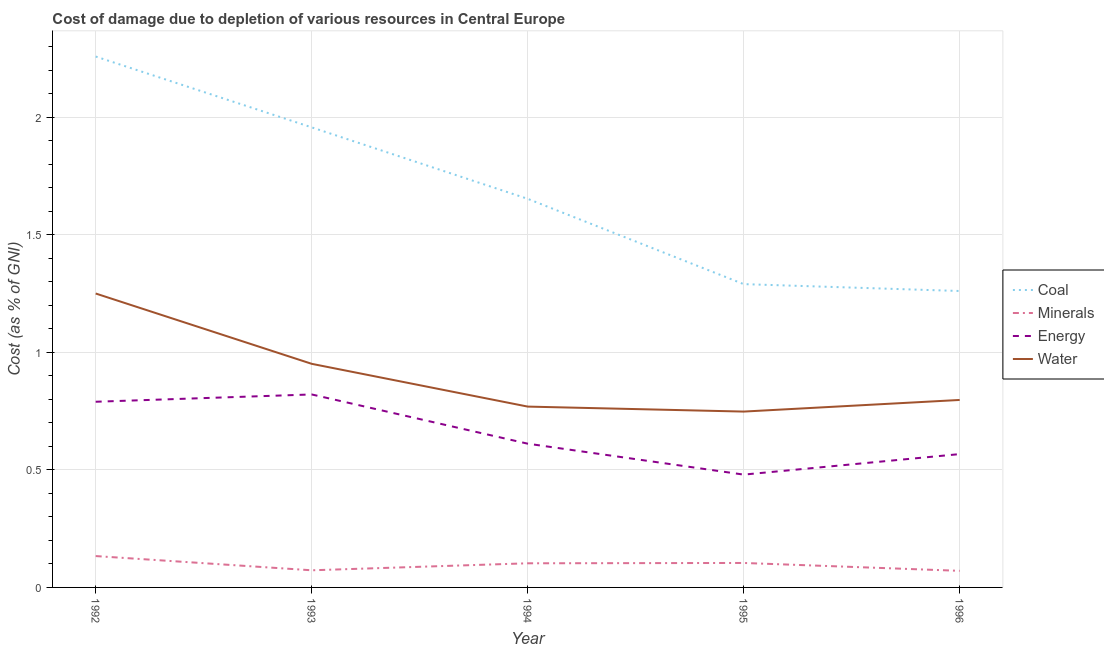How many different coloured lines are there?
Make the answer very short. 4. Does the line corresponding to cost of damage due to depletion of coal intersect with the line corresponding to cost of damage due to depletion of water?
Your answer should be compact. No. Is the number of lines equal to the number of legend labels?
Your answer should be compact. Yes. What is the cost of damage due to depletion of energy in 1996?
Your response must be concise. 0.57. Across all years, what is the maximum cost of damage due to depletion of energy?
Ensure brevity in your answer.  0.82. Across all years, what is the minimum cost of damage due to depletion of minerals?
Ensure brevity in your answer.  0.07. What is the total cost of damage due to depletion of energy in the graph?
Your answer should be very brief. 3.27. What is the difference between the cost of damage due to depletion of coal in 1995 and that in 1996?
Your answer should be very brief. 0.03. What is the difference between the cost of damage due to depletion of energy in 1994 and the cost of damage due to depletion of coal in 1995?
Give a very brief answer. -0.68. What is the average cost of damage due to depletion of minerals per year?
Your response must be concise. 0.1. In the year 1993, what is the difference between the cost of damage due to depletion of minerals and cost of damage due to depletion of coal?
Give a very brief answer. -1.88. In how many years, is the cost of damage due to depletion of water greater than 0.2 %?
Your response must be concise. 5. What is the ratio of the cost of damage due to depletion of minerals in 1992 to that in 1996?
Your response must be concise. 1.89. Is the difference between the cost of damage due to depletion of energy in 1993 and 1995 greater than the difference between the cost of damage due to depletion of water in 1993 and 1995?
Offer a terse response. Yes. What is the difference between the highest and the second highest cost of damage due to depletion of energy?
Give a very brief answer. 0.03. What is the difference between the highest and the lowest cost of damage due to depletion of minerals?
Keep it short and to the point. 0.06. Is the sum of the cost of damage due to depletion of minerals in 1992 and 1995 greater than the maximum cost of damage due to depletion of water across all years?
Provide a short and direct response. No. Is it the case that in every year, the sum of the cost of damage due to depletion of water and cost of damage due to depletion of energy is greater than the sum of cost of damage due to depletion of coal and cost of damage due to depletion of minerals?
Provide a short and direct response. No. Does the cost of damage due to depletion of minerals monotonically increase over the years?
Give a very brief answer. No. Is the cost of damage due to depletion of energy strictly less than the cost of damage due to depletion of coal over the years?
Offer a very short reply. Yes. What is the difference between two consecutive major ticks on the Y-axis?
Make the answer very short. 0.5. Are the values on the major ticks of Y-axis written in scientific E-notation?
Provide a short and direct response. No. Does the graph contain any zero values?
Your answer should be very brief. No. Does the graph contain grids?
Your answer should be compact. Yes. Where does the legend appear in the graph?
Your answer should be compact. Center right. What is the title of the graph?
Offer a very short reply. Cost of damage due to depletion of various resources in Central Europe . Does "First 20% of population" appear as one of the legend labels in the graph?
Offer a very short reply. No. What is the label or title of the Y-axis?
Keep it short and to the point. Cost (as % of GNI). What is the Cost (as % of GNI) in Coal in 1992?
Provide a succinct answer. 2.26. What is the Cost (as % of GNI) in Minerals in 1992?
Offer a terse response. 0.13. What is the Cost (as % of GNI) in Energy in 1992?
Offer a very short reply. 0.79. What is the Cost (as % of GNI) in Water in 1992?
Provide a succinct answer. 1.25. What is the Cost (as % of GNI) of Coal in 1993?
Make the answer very short. 1.96. What is the Cost (as % of GNI) in Minerals in 1993?
Your answer should be compact. 0.07. What is the Cost (as % of GNI) of Energy in 1993?
Make the answer very short. 0.82. What is the Cost (as % of GNI) in Water in 1993?
Your answer should be compact. 0.95. What is the Cost (as % of GNI) in Coal in 1994?
Provide a succinct answer. 1.65. What is the Cost (as % of GNI) of Minerals in 1994?
Make the answer very short. 0.1. What is the Cost (as % of GNI) in Energy in 1994?
Provide a succinct answer. 0.61. What is the Cost (as % of GNI) of Water in 1994?
Make the answer very short. 0.77. What is the Cost (as % of GNI) of Coal in 1995?
Offer a terse response. 1.29. What is the Cost (as % of GNI) of Minerals in 1995?
Keep it short and to the point. 0.1. What is the Cost (as % of GNI) in Energy in 1995?
Your answer should be very brief. 0.48. What is the Cost (as % of GNI) of Water in 1995?
Your response must be concise. 0.75. What is the Cost (as % of GNI) of Coal in 1996?
Provide a short and direct response. 1.26. What is the Cost (as % of GNI) of Minerals in 1996?
Provide a succinct answer. 0.07. What is the Cost (as % of GNI) in Energy in 1996?
Make the answer very short. 0.57. What is the Cost (as % of GNI) in Water in 1996?
Provide a succinct answer. 0.8. Across all years, what is the maximum Cost (as % of GNI) of Coal?
Ensure brevity in your answer.  2.26. Across all years, what is the maximum Cost (as % of GNI) in Minerals?
Offer a very short reply. 0.13. Across all years, what is the maximum Cost (as % of GNI) in Energy?
Provide a succinct answer. 0.82. Across all years, what is the maximum Cost (as % of GNI) of Water?
Ensure brevity in your answer.  1.25. Across all years, what is the minimum Cost (as % of GNI) in Coal?
Your answer should be compact. 1.26. Across all years, what is the minimum Cost (as % of GNI) of Minerals?
Your response must be concise. 0.07. Across all years, what is the minimum Cost (as % of GNI) of Energy?
Offer a terse response. 0.48. Across all years, what is the minimum Cost (as % of GNI) in Water?
Keep it short and to the point. 0.75. What is the total Cost (as % of GNI) of Coal in the graph?
Your response must be concise. 8.42. What is the total Cost (as % of GNI) of Minerals in the graph?
Give a very brief answer. 0.48. What is the total Cost (as % of GNI) of Energy in the graph?
Provide a short and direct response. 3.27. What is the total Cost (as % of GNI) of Water in the graph?
Ensure brevity in your answer.  4.52. What is the difference between the Cost (as % of GNI) of Coal in 1992 and that in 1993?
Offer a terse response. 0.3. What is the difference between the Cost (as % of GNI) of Minerals in 1992 and that in 1993?
Keep it short and to the point. 0.06. What is the difference between the Cost (as % of GNI) in Energy in 1992 and that in 1993?
Your response must be concise. -0.03. What is the difference between the Cost (as % of GNI) of Water in 1992 and that in 1993?
Your answer should be compact. 0.3. What is the difference between the Cost (as % of GNI) of Coal in 1992 and that in 1994?
Keep it short and to the point. 0.61. What is the difference between the Cost (as % of GNI) in Minerals in 1992 and that in 1994?
Give a very brief answer. 0.03. What is the difference between the Cost (as % of GNI) of Energy in 1992 and that in 1994?
Keep it short and to the point. 0.18. What is the difference between the Cost (as % of GNI) in Water in 1992 and that in 1994?
Provide a succinct answer. 0.48. What is the difference between the Cost (as % of GNI) in Coal in 1992 and that in 1995?
Your answer should be very brief. 0.97. What is the difference between the Cost (as % of GNI) of Minerals in 1992 and that in 1995?
Your answer should be compact. 0.03. What is the difference between the Cost (as % of GNI) in Energy in 1992 and that in 1995?
Provide a short and direct response. 0.31. What is the difference between the Cost (as % of GNI) in Water in 1992 and that in 1995?
Your answer should be very brief. 0.5. What is the difference between the Cost (as % of GNI) of Coal in 1992 and that in 1996?
Provide a short and direct response. 1. What is the difference between the Cost (as % of GNI) of Minerals in 1992 and that in 1996?
Make the answer very short. 0.06. What is the difference between the Cost (as % of GNI) in Energy in 1992 and that in 1996?
Offer a terse response. 0.22. What is the difference between the Cost (as % of GNI) in Water in 1992 and that in 1996?
Keep it short and to the point. 0.45. What is the difference between the Cost (as % of GNI) of Coal in 1993 and that in 1994?
Offer a terse response. 0.3. What is the difference between the Cost (as % of GNI) in Minerals in 1993 and that in 1994?
Offer a terse response. -0.03. What is the difference between the Cost (as % of GNI) of Energy in 1993 and that in 1994?
Provide a short and direct response. 0.21. What is the difference between the Cost (as % of GNI) of Water in 1993 and that in 1994?
Your answer should be very brief. 0.18. What is the difference between the Cost (as % of GNI) of Coal in 1993 and that in 1995?
Make the answer very short. 0.67. What is the difference between the Cost (as % of GNI) of Minerals in 1993 and that in 1995?
Your answer should be very brief. -0.03. What is the difference between the Cost (as % of GNI) of Energy in 1993 and that in 1995?
Give a very brief answer. 0.34. What is the difference between the Cost (as % of GNI) of Water in 1993 and that in 1995?
Your answer should be compact. 0.2. What is the difference between the Cost (as % of GNI) in Coal in 1993 and that in 1996?
Ensure brevity in your answer.  0.7. What is the difference between the Cost (as % of GNI) of Minerals in 1993 and that in 1996?
Provide a succinct answer. 0. What is the difference between the Cost (as % of GNI) of Energy in 1993 and that in 1996?
Your answer should be compact. 0.25. What is the difference between the Cost (as % of GNI) of Water in 1993 and that in 1996?
Offer a terse response. 0.15. What is the difference between the Cost (as % of GNI) in Coal in 1994 and that in 1995?
Provide a succinct answer. 0.36. What is the difference between the Cost (as % of GNI) in Minerals in 1994 and that in 1995?
Offer a very short reply. -0. What is the difference between the Cost (as % of GNI) of Energy in 1994 and that in 1995?
Offer a very short reply. 0.13. What is the difference between the Cost (as % of GNI) in Water in 1994 and that in 1995?
Give a very brief answer. 0.02. What is the difference between the Cost (as % of GNI) of Coal in 1994 and that in 1996?
Keep it short and to the point. 0.39. What is the difference between the Cost (as % of GNI) of Minerals in 1994 and that in 1996?
Ensure brevity in your answer.  0.03. What is the difference between the Cost (as % of GNI) of Energy in 1994 and that in 1996?
Give a very brief answer. 0.04. What is the difference between the Cost (as % of GNI) of Water in 1994 and that in 1996?
Provide a succinct answer. -0.03. What is the difference between the Cost (as % of GNI) of Coal in 1995 and that in 1996?
Provide a short and direct response. 0.03. What is the difference between the Cost (as % of GNI) of Minerals in 1995 and that in 1996?
Provide a short and direct response. 0.03. What is the difference between the Cost (as % of GNI) in Energy in 1995 and that in 1996?
Offer a very short reply. -0.09. What is the difference between the Cost (as % of GNI) of Water in 1995 and that in 1996?
Ensure brevity in your answer.  -0.05. What is the difference between the Cost (as % of GNI) in Coal in 1992 and the Cost (as % of GNI) in Minerals in 1993?
Provide a short and direct response. 2.19. What is the difference between the Cost (as % of GNI) in Coal in 1992 and the Cost (as % of GNI) in Energy in 1993?
Ensure brevity in your answer.  1.44. What is the difference between the Cost (as % of GNI) of Coal in 1992 and the Cost (as % of GNI) of Water in 1993?
Provide a succinct answer. 1.31. What is the difference between the Cost (as % of GNI) in Minerals in 1992 and the Cost (as % of GNI) in Energy in 1993?
Your answer should be compact. -0.69. What is the difference between the Cost (as % of GNI) of Minerals in 1992 and the Cost (as % of GNI) of Water in 1993?
Provide a short and direct response. -0.82. What is the difference between the Cost (as % of GNI) in Energy in 1992 and the Cost (as % of GNI) in Water in 1993?
Offer a terse response. -0.16. What is the difference between the Cost (as % of GNI) of Coal in 1992 and the Cost (as % of GNI) of Minerals in 1994?
Offer a very short reply. 2.16. What is the difference between the Cost (as % of GNI) in Coal in 1992 and the Cost (as % of GNI) in Energy in 1994?
Give a very brief answer. 1.65. What is the difference between the Cost (as % of GNI) of Coal in 1992 and the Cost (as % of GNI) of Water in 1994?
Keep it short and to the point. 1.49. What is the difference between the Cost (as % of GNI) of Minerals in 1992 and the Cost (as % of GNI) of Energy in 1994?
Your answer should be very brief. -0.48. What is the difference between the Cost (as % of GNI) of Minerals in 1992 and the Cost (as % of GNI) of Water in 1994?
Offer a very short reply. -0.64. What is the difference between the Cost (as % of GNI) in Energy in 1992 and the Cost (as % of GNI) in Water in 1994?
Offer a very short reply. 0.02. What is the difference between the Cost (as % of GNI) in Coal in 1992 and the Cost (as % of GNI) in Minerals in 1995?
Keep it short and to the point. 2.15. What is the difference between the Cost (as % of GNI) of Coal in 1992 and the Cost (as % of GNI) of Energy in 1995?
Offer a very short reply. 1.78. What is the difference between the Cost (as % of GNI) in Coal in 1992 and the Cost (as % of GNI) in Water in 1995?
Provide a short and direct response. 1.51. What is the difference between the Cost (as % of GNI) in Minerals in 1992 and the Cost (as % of GNI) in Energy in 1995?
Give a very brief answer. -0.35. What is the difference between the Cost (as % of GNI) in Minerals in 1992 and the Cost (as % of GNI) in Water in 1995?
Offer a terse response. -0.61. What is the difference between the Cost (as % of GNI) of Energy in 1992 and the Cost (as % of GNI) of Water in 1995?
Keep it short and to the point. 0.04. What is the difference between the Cost (as % of GNI) of Coal in 1992 and the Cost (as % of GNI) of Minerals in 1996?
Make the answer very short. 2.19. What is the difference between the Cost (as % of GNI) of Coal in 1992 and the Cost (as % of GNI) of Energy in 1996?
Offer a very short reply. 1.69. What is the difference between the Cost (as % of GNI) in Coal in 1992 and the Cost (as % of GNI) in Water in 1996?
Offer a terse response. 1.46. What is the difference between the Cost (as % of GNI) in Minerals in 1992 and the Cost (as % of GNI) in Energy in 1996?
Keep it short and to the point. -0.43. What is the difference between the Cost (as % of GNI) in Minerals in 1992 and the Cost (as % of GNI) in Water in 1996?
Make the answer very short. -0.66. What is the difference between the Cost (as % of GNI) of Energy in 1992 and the Cost (as % of GNI) of Water in 1996?
Your answer should be compact. -0.01. What is the difference between the Cost (as % of GNI) in Coal in 1993 and the Cost (as % of GNI) in Minerals in 1994?
Make the answer very short. 1.85. What is the difference between the Cost (as % of GNI) in Coal in 1993 and the Cost (as % of GNI) in Energy in 1994?
Keep it short and to the point. 1.35. What is the difference between the Cost (as % of GNI) in Coal in 1993 and the Cost (as % of GNI) in Water in 1994?
Offer a very short reply. 1.19. What is the difference between the Cost (as % of GNI) of Minerals in 1993 and the Cost (as % of GNI) of Energy in 1994?
Give a very brief answer. -0.54. What is the difference between the Cost (as % of GNI) in Minerals in 1993 and the Cost (as % of GNI) in Water in 1994?
Your answer should be very brief. -0.7. What is the difference between the Cost (as % of GNI) of Energy in 1993 and the Cost (as % of GNI) of Water in 1994?
Your answer should be compact. 0.05. What is the difference between the Cost (as % of GNI) in Coal in 1993 and the Cost (as % of GNI) in Minerals in 1995?
Keep it short and to the point. 1.85. What is the difference between the Cost (as % of GNI) in Coal in 1993 and the Cost (as % of GNI) in Energy in 1995?
Provide a short and direct response. 1.48. What is the difference between the Cost (as % of GNI) in Coal in 1993 and the Cost (as % of GNI) in Water in 1995?
Keep it short and to the point. 1.21. What is the difference between the Cost (as % of GNI) of Minerals in 1993 and the Cost (as % of GNI) of Energy in 1995?
Your answer should be compact. -0.41. What is the difference between the Cost (as % of GNI) in Minerals in 1993 and the Cost (as % of GNI) in Water in 1995?
Your answer should be compact. -0.68. What is the difference between the Cost (as % of GNI) of Energy in 1993 and the Cost (as % of GNI) of Water in 1995?
Keep it short and to the point. 0.07. What is the difference between the Cost (as % of GNI) of Coal in 1993 and the Cost (as % of GNI) of Minerals in 1996?
Your answer should be compact. 1.89. What is the difference between the Cost (as % of GNI) in Coal in 1993 and the Cost (as % of GNI) in Energy in 1996?
Keep it short and to the point. 1.39. What is the difference between the Cost (as % of GNI) in Coal in 1993 and the Cost (as % of GNI) in Water in 1996?
Ensure brevity in your answer.  1.16. What is the difference between the Cost (as % of GNI) of Minerals in 1993 and the Cost (as % of GNI) of Energy in 1996?
Provide a succinct answer. -0.49. What is the difference between the Cost (as % of GNI) of Minerals in 1993 and the Cost (as % of GNI) of Water in 1996?
Your answer should be very brief. -0.72. What is the difference between the Cost (as % of GNI) of Energy in 1993 and the Cost (as % of GNI) of Water in 1996?
Your response must be concise. 0.02. What is the difference between the Cost (as % of GNI) in Coal in 1994 and the Cost (as % of GNI) in Minerals in 1995?
Your response must be concise. 1.55. What is the difference between the Cost (as % of GNI) in Coal in 1994 and the Cost (as % of GNI) in Energy in 1995?
Offer a very short reply. 1.17. What is the difference between the Cost (as % of GNI) in Coal in 1994 and the Cost (as % of GNI) in Water in 1995?
Your answer should be compact. 0.91. What is the difference between the Cost (as % of GNI) of Minerals in 1994 and the Cost (as % of GNI) of Energy in 1995?
Your answer should be compact. -0.38. What is the difference between the Cost (as % of GNI) of Minerals in 1994 and the Cost (as % of GNI) of Water in 1995?
Your response must be concise. -0.65. What is the difference between the Cost (as % of GNI) in Energy in 1994 and the Cost (as % of GNI) in Water in 1995?
Your answer should be compact. -0.14. What is the difference between the Cost (as % of GNI) in Coal in 1994 and the Cost (as % of GNI) in Minerals in 1996?
Your response must be concise. 1.58. What is the difference between the Cost (as % of GNI) in Coal in 1994 and the Cost (as % of GNI) in Energy in 1996?
Your answer should be very brief. 1.09. What is the difference between the Cost (as % of GNI) in Coal in 1994 and the Cost (as % of GNI) in Water in 1996?
Give a very brief answer. 0.86. What is the difference between the Cost (as % of GNI) of Minerals in 1994 and the Cost (as % of GNI) of Energy in 1996?
Give a very brief answer. -0.46. What is the difference between the Cost (as % of GNI) in Minerals in 1994 and the Cost (as % of GNI) in Water in 1996?
Ensure brevity in your answer.  -0.69. What is the difference between the Cost (as % of GNI) in Energy in 1994 and the Cost (as % of GNI) in Water in 1996?
Your answer should be compact. -0.19. What is the difference between the Cost (as % of GNI) of Coal in 1995 and the Cost (as % of GNI) of Minerals in 1996?
Make the answer very short. 1.22. What is the difference between the Cost (as % of GNI) in Coal in 1995 and the Cost (as % of GNI) in Energy in 1996?
Give a very brief answer. 0.72. What is the difference between the Cost (as % of GNI) in Coal in 1995 and the Cost (as % of GNI) in Water in 1996?
Make the answer very short. 0.49. What is the difference between the Cost (as % of GNI) of Minerals in 1995 and the Cost (as % of GNI) of Energy in 1996?
Provide a short and direct response. -0.46. What is the difference between the Cost (as % of GNI) of Minerals in 1995 and the Cost (as % of GNI) of Water in 1996?
Your response must be concise. -0.69. What is the difference between the Cost (as % of GNI) of Energy in 1995 and the Cost (as % of GNI) of Water in 1996?
Give a very brief answer. -0.32. What is the average Cost (as % of GNI) of Coal per year?
Offer a very short reply. 1.68. What is the average Cost (as % of GNI) in Minerals per year?
Ensure brevity in your answer.  0.1. What is the average Cost (as % of GNI) in Energy per year?
Offer a very short reply. 0.65. What is the average Cost (as % of GNI) in Water per year?
Make the answer very short. 0.9. In the year 1992, what is the difference between the Cost (as % of GNI) of Coal and Cost (as % of GNI) of Minerals?
Ensure brevity in your answer.  2.12. In the year 1992, what is the difference between the Cost (as % of GNI) in Coal and Cost (as % of GNI) in Energy?
Offer a terse response. 1.47. In the year 1992, what is the difference between the Cost (as % of GNI) in Coal and Cost (as % of GNI) in Water?
Give a very brief answer. 1.01. In the year 1992, what is the difference between the Cost (as % of GNI) in Minerals and Cost (as % of GNI) in Energy?
Your response must be concise. -0.66. In the year 1992, what is the difference between the Cost (as % of GNI) in Minerals and Cost (as % of GNI) in Water?
Make the answer very short. -1.12. In the year 1992, what is the difference between the Cost (as % of GNI) in Energy and Cost (as % of GNI) in Water?
Make the answer very short. -0.46. In the year 1993, what is the difference between the Cost (as % of GNI) in Coal and Cost (as % of GNI) in Minerals?
Offer a very short reply. 1.88. In the year 1993, what is the difference between the Cost (as % of GNI) in Coal and Cost (as % of GNI) in Energy?
Your answer should be very brief. 1.14. In the year 1993, what is the difference between the Cost (as % of GNI) of Coal and Cost (as % of GNI) of Water?
Make the answer very short. 1.01. In the year 1993, what is the difference between the Cost (as % of GNI) in Minerals and Cost (as % of GNI) in Energy?
Give a very brief answer. -0.75. In the year 1993, what is the difference between the Cost (as % of GNI) in Minerals and Cost (as % of GNI) in Water?
Provide a succinct answer. -0.88. In the year 1993, what is the difference between the Cost (as % of GNI) of Energy and Cost (as % of GNI) of Water?
Ensure brevity in your answer.  -0.13. In the year 1994, what is the difference between the Cost (as % of GNI) of Coal and Cost (as % of GNI) of Minerals?
Your answer should be very brief. 1.55. In the year 1994, what is the difference between the Cost (as % of GNI) of Coal and Cost (as % of GNI) of Energy?
Provide a succinct answer. 1.04. In the year 1994, what is the difference between the Cost (as % of GNI) of Coal and Cost (as % of GNI) of Water?
Offer a very short reply. 0.88. In the year 1994, what is the difference between the Cost (as % of GNI) of Minerals and Cost (as % of GNI) of Energy?
Keep it short and to the point. -0.51. In the year 1994, what is the difference between the Cost (as % of GNI) in Minerals and Cost (as % of GNI) in Water?
Your answer should be very brief. -0.67. In the year 1994, what is the difference between the Cost (as % of GNI) of Energy and Cost (as % of GNI) of Water?
Ensure brevity in your answer.  -0.16. In the year 1995, what is the difference between the Cost (as % of GNI) of Coal and Cost (as % of GNI) of Minerals?
Keep it short and to the point. 1.19. In the year 1995, what is the difference between the Cost (as % of GNI) of Coal and Cost (as % of GNI) of Energy?
Offer a very short reply. 0.81. In the year 1995, what is the difference between the Cost (as % of GNI) of Coal and Cost (as % of GNI) of Water?
Ensure brevity in your answer.  0.54. In the year 1995, what is the difference between the Cost (as % of GNI) in Minerals and Cost (as % of GNI) in Energy?
Give a very brief answer. -0.38. In the year 1995, what is the difference between the Cost (as % of GNI) of Minerals and Cost (as % of GNI) of Water?
Make the answer very short. -0.64. In the year 1995, what is the difference between the Cost (as % of GNI) in Energy and Cost (as % of GNI) in Water?
Offer a very short reply. -0.27. In the year 1996, what is the difference between the Cost (as % of GNI) of Coal and Cost (as % of GNI) of Minerals?
Make the answer very short. 1.19. In the year 1996, what is the difference between the Cost (as % of GNI) in Coal and Cost (as % of GNI) in Energy?
Offer a very short reply. 0.69. In the year 1996, what is the difference between the Cost (as % of GNI) in Coal and Cost (as % of GNI) in Water?
Make the answer very short. 0.46. In the year 1996, what is the difference between the Cost (as % of GNI) in Minerals and Cost (as % of GNI) in Energy?
Offer a terse response. -0.5. In the year 1996, what is the difference between the Cost (as % of GNI) of Minerals and Cost (as % of GNI) of Water?
Ensure brevity in your answer.  -0.73. In the year 1996, what is the difference between the Cost (as % of GNI) of Energy and Cost (as % of GNI) of Water?
Keep it short and to the point. -0.23. What is the ratio of the Cost (as % of GNI) in Coal in 1992 to that in 1993?
Give a very brief answer. 1.15. What is the ratio of the Cost (as % of GNI) of Minerals in 1992 to that in 1993?
Your answer should be very brief. 1.83. What is the ratio of the Cost (as % of GNI) in Energy in 1992 to that in 1993?
Ensure brevity in your answer.  0.96. What is the ratio of the Cost (as % of GNI) of Water in 1992 to that in 1993?
Offer a very short reply. 1.31. What is the ratio of the Cost (as % of GNI) of Coal in 1992 to that in 1994?
Keep it short and to the point. 1.37. What is the ratio of the Cost (as % of GNI) in Minerals in 1992 to that in 1994?
Keep it short and to the point. 1.3. What is the ratio of the Cost (as % of GNI) in Energy in 1992 to that in 1994?
Give a very brief answer. 1.29. What is the ratio of the Cost (as % of GNI) of Water in 1992 to that in 1994?
Offer a very short reply. 1.63. What is the ratio of the Cost (as % of GNI) of Coal in 1992 to that in 1995?
Ensure brevity in your answer.  1.75. What is the ratio of the Cost (as % of GNI) in Minerals in 1992 to that in 1995?
Offer a very short reply. 1.28. What is the ratio of the Cost (as % of GNI) of Energy in 1992 to that in 1995?
Make the answer very short. 1.65. What is the ratio of the Cost (as % of GNI) of Water in 1992 to that in 1995?
Offer a terse response. 1.67. What is the ratio of the Cost (as % of GNI) in Coal in 1992 to that in 1996?
Provide a succinct answer. 1.79. What is the ratio of the Cost (as % of GNI) in Minerals in 1992 to that in 1996?
Keep it short and to the point. 1.89. What is the ratio of the Cost (as % of GNI) of Energy in 1992 to that in 1996?
Ensure brevity in your answer.  1.39. What is the ratio of the Cost (as % of GNI) in Water in 1992 to that in 1996?
Keep it short and to the point. 1.57. What is the ratio of the Cost (as % of GNI) of Coal in 1993 to that in 1994?
Keep it short and to the point. 1.18. What is the ratio of the Cost (as % of GNI) in Minerals in 1993 to that in 1994?
Offer a terse response. 0.71. What is the ratio of the Cost (as % of GNI) in Energy in 1993 to that in 1994?
Provide a succinct answer. 1.34. What is the ratio of the Cost (as % of GNI) of Water in 1993 to that in 1994?
Provide a succinct answer. 1.24. What is the ratio of the Cost (as % of GNI) of Coal in 1993 to that in 1995?
Offer a very short reply. 1.52. What is the ratio of the Cost (as % of GNI) of Minerals in 1993 to that in 1995?
Keep it short and to the point. 0.7. What is the ratio of the Cost (as % of GNI) in Energy in 1993 to that in 1995?
Offer a very short reply. 1.71. What is the ratio of the Cost (as % of GNI) in Water in 1993 to that in 1995?
Offer a very short reply. 1.27. What is the ratio of the Cost (as % of GNI) in Coal in 1993 to that in 1996?
Give a very brief answer. 1.55. What is the ratio of the Cost (as % of GNI) of Minerals in 1993 to that in 1996?
Your response must be concise. 1.03. What is the ratio of the Cost (as % of GNI) in Energy in 1993 to that in 1996?
Your answer should be very brief. 1.45. What is the ratio of the Cost (as % of GNI) of Water in 1993 to that in 1996?
Your answer should be very brief. 1.19. What is the ratio of the Cost (as % of GNI) of Coal in 1994 to that in 1995?
Make the answer very short. 1.28. What is the ratio of the Cost (as % of GNI) of Minerals in 1994 to that in 1995?
Make the answer very short. 0.99. What is the ratio of the Cost (as % of GNI) of Energy in 1994 to that in 1995?
Your answer should be compact. 1.27. What is the ratio of the Cost (as % of GNI) of Water in 1994 to that in 1995?
Keep it short and to the point. 1.03. What is the ratio of the Cost (as % of GNI) of Coal in 1994 to that in 1996?
Your answer should be compact. 1.31. What is the ratio of the Cost (as % of GNI) of Minerals in 1994 to that in 1996?
Ensure brevity in your answer.  1.45. What is the ratio of the Cost (as % of GNI) in Energy in 1994 to that in 1996?
Provide a succinct answer. 1.08. What is the ratio of the Cost (as % of GNI) in Water in 1994 to that in 1996?
Ensure brevity in your answer.  0.96. What is the ratio of the Cost (as % of GNI) in Coal in 1995 to that in 1996?
Keep it short and to the point. 1.02. What is the ratio of the Cost (as % of GNI) in Minerals in 1995 to that in 1996?
Your response must be concise. 1.47. What is the ratio of the Cost (as % of GNI) in Energy in 1995 to that in 1996?
Offer a terse response. 0.85. What is the ratio of the Cost (as % of GNI) in Water in 1995 to that in 1996?
Your answer should be very brief. 0.94. What is the difference between the highest and the second highest Cost (as % of GNI) of Coal?
Give a very brief answer. 0.3. What is the difference between the highest and the second highest Cost (as % of GNI) of Minerals?
Offer a very short reply. 0.03. What is the difference between the highest and the second highest Cost (as % of GNI) in Energy?
Ensure brevity in your answer.  0.03. What is the difference between the highest and the second highest Cost (as % of GNI) of Water?
Offer a very short reply. 0.3. What is the difference between the highest and the lowest Cost (as % of GNI) of Coal?
Make the answer very short. 1. What is the difference between the highest and the lowest Cost (as % of GNI) of Minerals?
Provide a short and direct response. 0.06. What is the difference between the highest and the lowest Cost (as % of GNI) in Energy?
Your answer should be very brief. 0.34. What is the difference between the highest and the lowest Cost (as % of GNI) in Water?
Offer a very short reply. 0.5. 